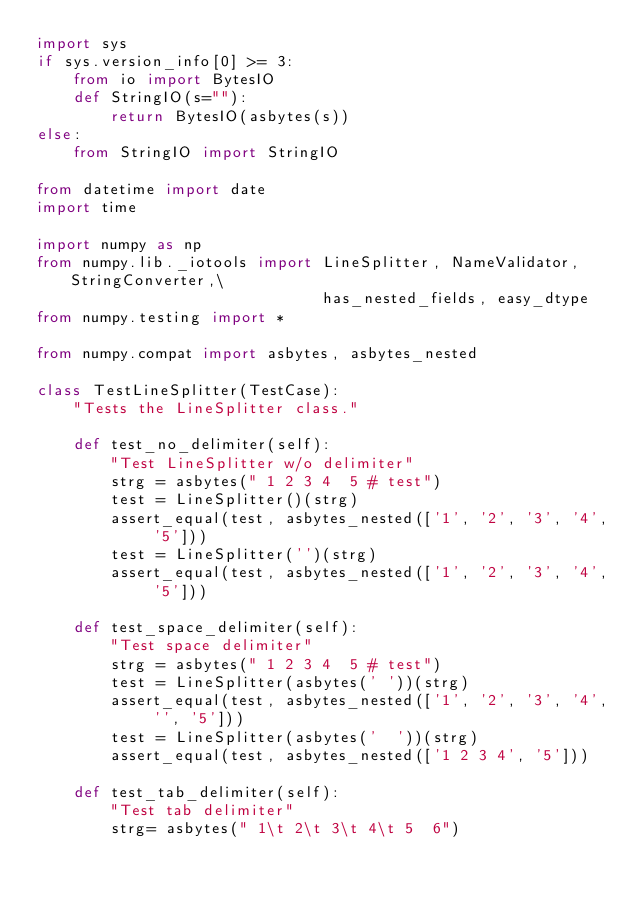<code> <loc_0><loc_0><loc_500><loc_500><_Python_>import sys
if sys.version_info[0] >= 3:
    from io import BytesIO
    def StringIO(s=""):
        return BytesIO(asbytes(s))
else:
    from StringIO import StringIO

from datetime import date
import time

import numpy as np
from numpy.lib._iotools import LineSplitter, NameValidator, StringConverter,\
                               has_nested_fields, easy_dtype
from numpy.testing import *

from numpy.compat import asbytes, asbytes_nested

class TestLineSplitter(TestCase):
    "Tests the LineSplitter class."

    def test_no_delimiter(self):
        "Test LineSplitter w/o delimiter"
        strg = asbytes(" 1 2 3 4  5 # test")
        test = LineSplitter()(strg)
        assert_equal(test, asbytes_nested(['1', '2', '3', '4', '5']))
        test = LineSplitter('')(strg)
        assert_equal(test, asbytes_nested(['1', '2', '3', '4', '5']))

    def test_space_delimiter(self):
        "Test space delimiter"
        strg = asbytes(" 1 2 3 4  5 # test")
        test = LineSplitter(asbytes(' '))(strg)
        assert_equal(test, asbytes_nested(['1', '2', '3', '4', '', '5']))
        test = LineSplitter(asbytes('  '))(strg)
        assert_equal(test, asbytes_nested(['1 2 3 4', '5']))

    def test_tab_delimiter(self):
        "Test tab delimiter"
        strg= asbytes(" 1\t 2\t 3\t 4\t 5  6")</code> 